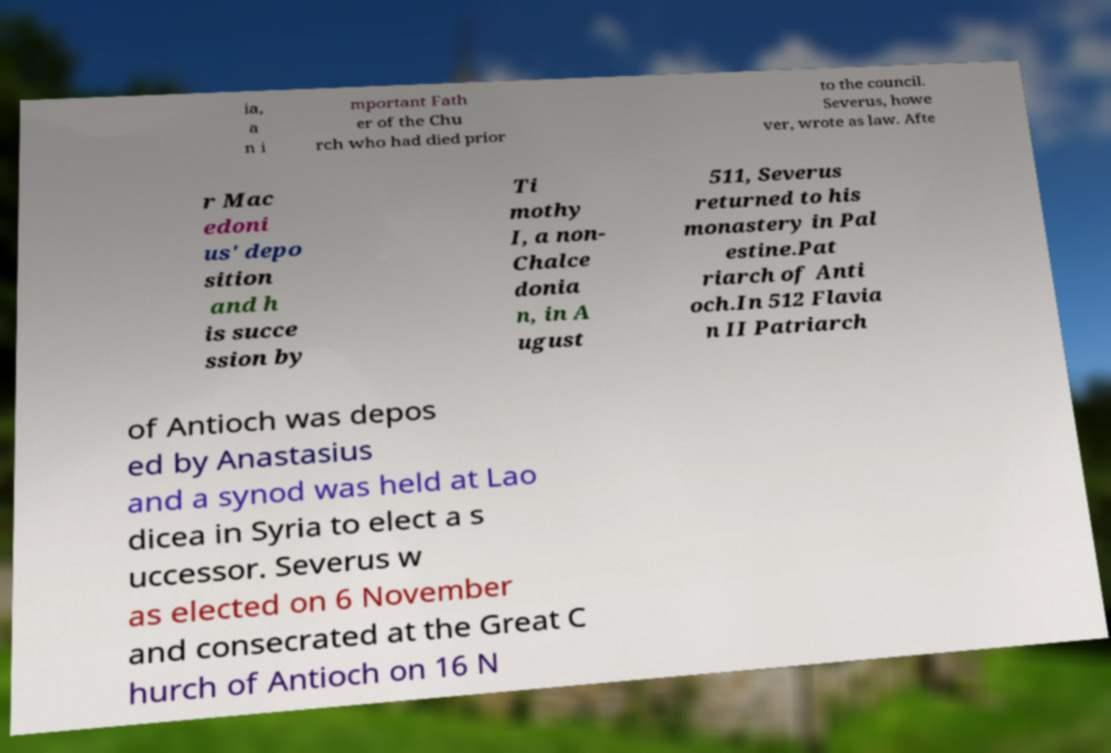Can you read and provide the text displayed in the image?This photo seems to have some interesting text. Can you extract and type it out for me? ia, a n i mportant Fath er of the Chu rch who had died prior to the council. Severus, howe ver, wrote as law. Afte r Mac edoni us' depo sition and h is succe ssion by Ti mothy I, a non- Chalce donia n, in A ugust 511, Severus returned to his monastery in Pal estine.Pat riarch of Anti och.In 512 Flavia n II Patriarch of Antioch was depos ed by Anastasius and a synod was held at Lao dicea in Syria to elect a s uccessor. Severus w as elected on 6 November and consecrated at the Great C hurch of Antioch on 16 N 